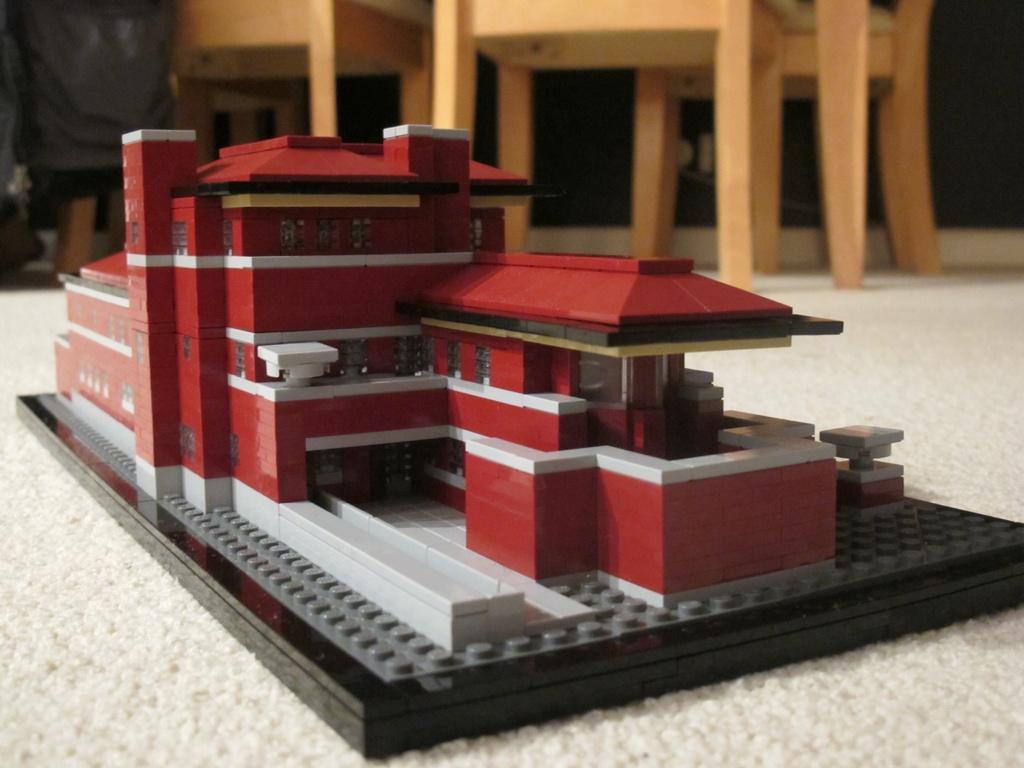Please provide a concise description of this image. In the center of the image, we can see an architecture of a building, which is on the mat and in the background, there are chairs. 